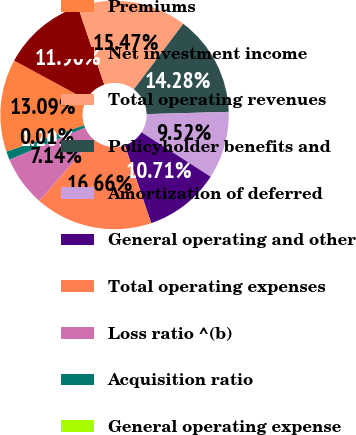Convert chart to OTSL. <chart><loc_0><loc_0><loc_500><loc_500><pie_chart><fcel>Premiums<fcel>Net investment income<fcel>Total operating revenues<fcel>Policyholder benefits and<fcel>Amortization of deferred<fcel>General operating and other<fcel>Total operating expenses<fcel>Loss ratio ^(b)<fcel>Acquisition ratio<fcel>General operating expense<nl><fcel>13.09%<fcel>11.9%<fcel>15.47%<fcel>14.28%<fcel>9.52%<fcel>10.71%<fcel>16.66%<fcel>7.14%<fcel>1.2%<fcel>0.01%<nl></chart> 